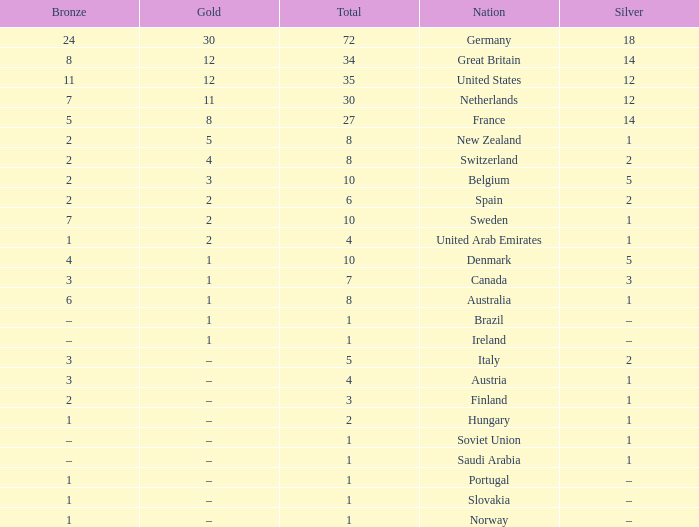What is Bronze, when Silver is 2, and when Nation is Italy? 3.0. 